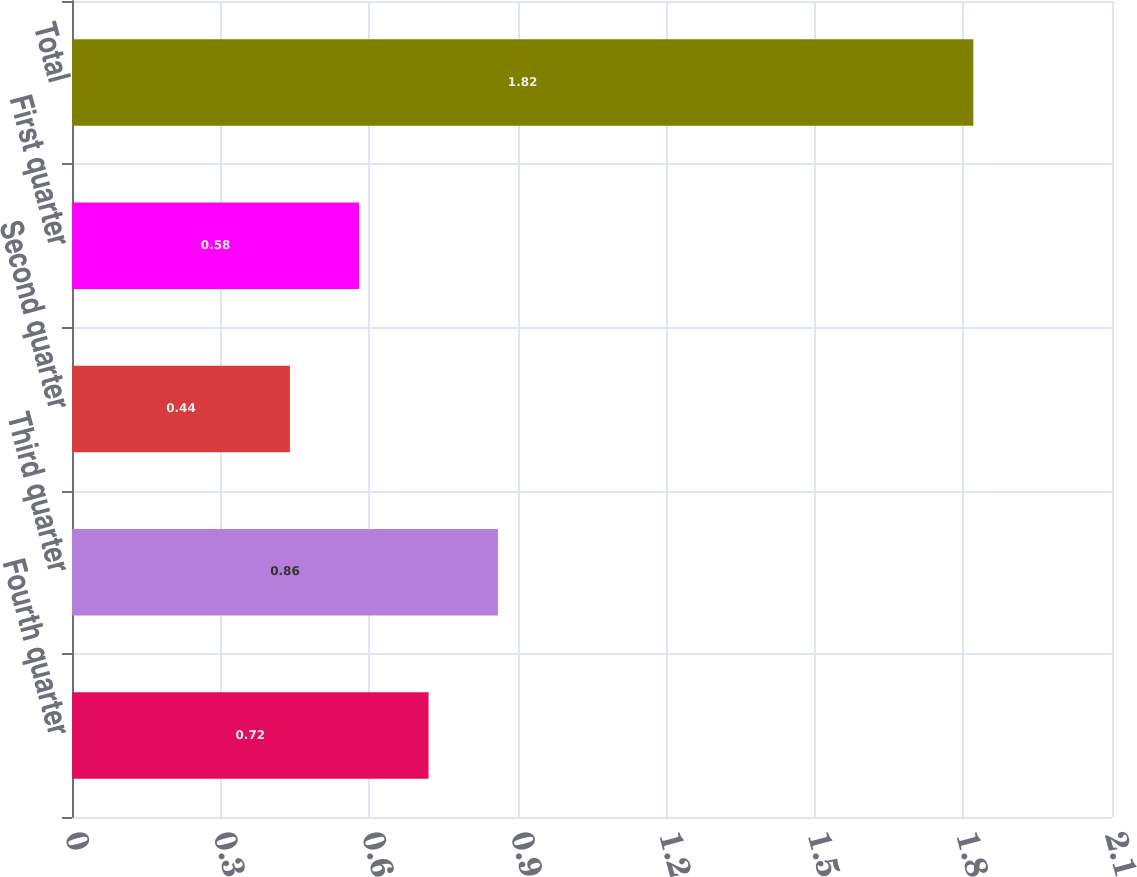Convert chart. <chart><loc_0><loc_0><loc_500><loc_500><bar_chart><fcel>Fourth quarter<fcel>Third quarter<fcel>Second quarter<fcel>First quarter<fcel>Total<nl><fcel>0.72<fcel>0.86<fcel>0.44<fcel>0.58<fcel>1.82<nl></chart> 